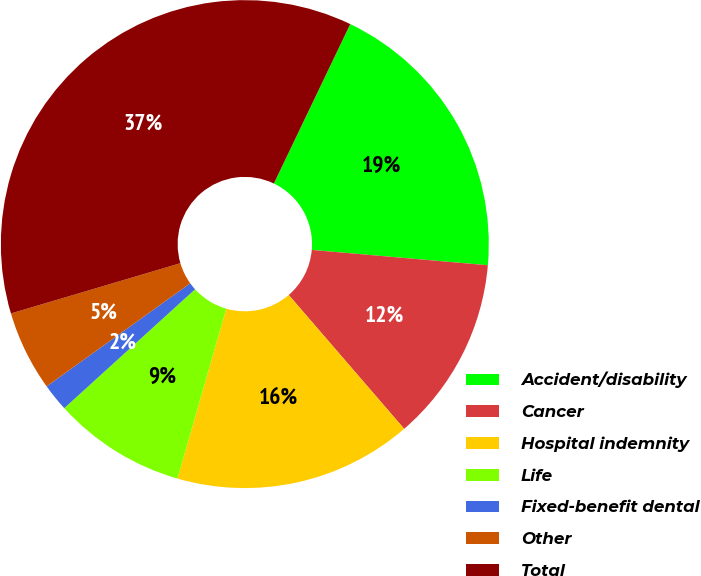Convert chart. <chart><loc_0><loc_0><loc_500><loc_500><pie_chart><fcel>Accident/disability<fcel>Cancer<fcel>Hospital indemnity<fcel>Life<fcel>Fixed-benefit dental<fcel>Other<fcel>Total<nl><fcel>19.27%<fcel>12.29%<fcel>15.78%<fcel>8.81%<fcel>1.83%<fcel>5.32%<fcel>36.7%<nl></chart> 